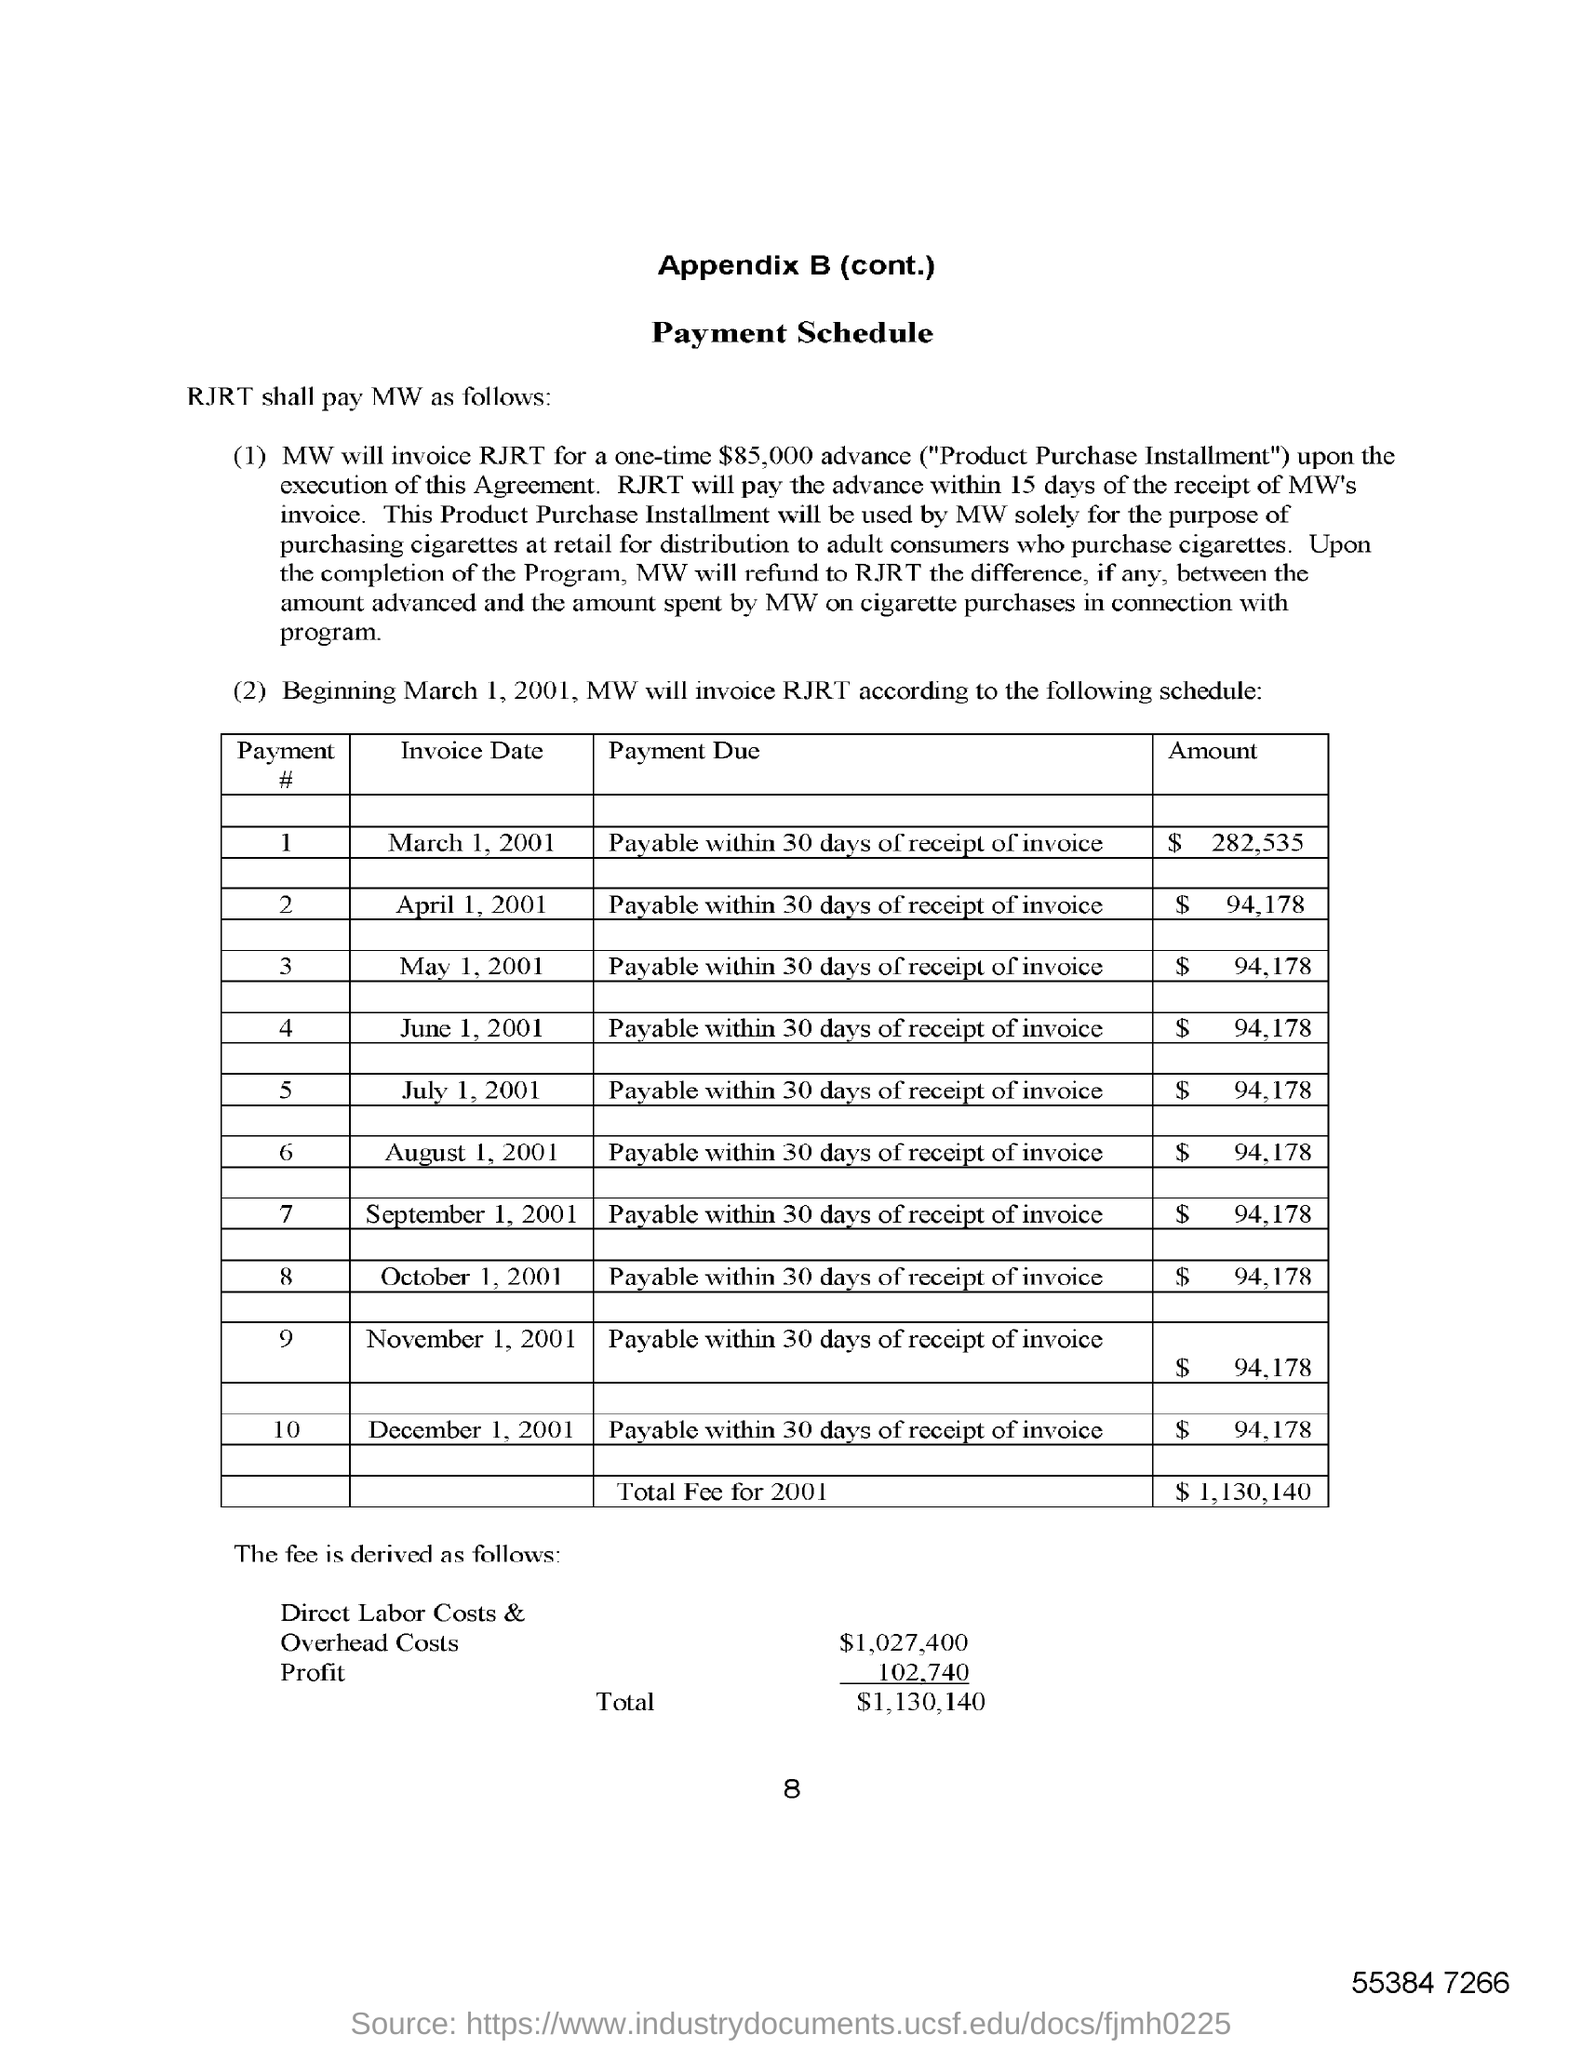Draw attention to some important aspects in this diagram. The direct labor costs and overhead costs amount to $1,027,400. 